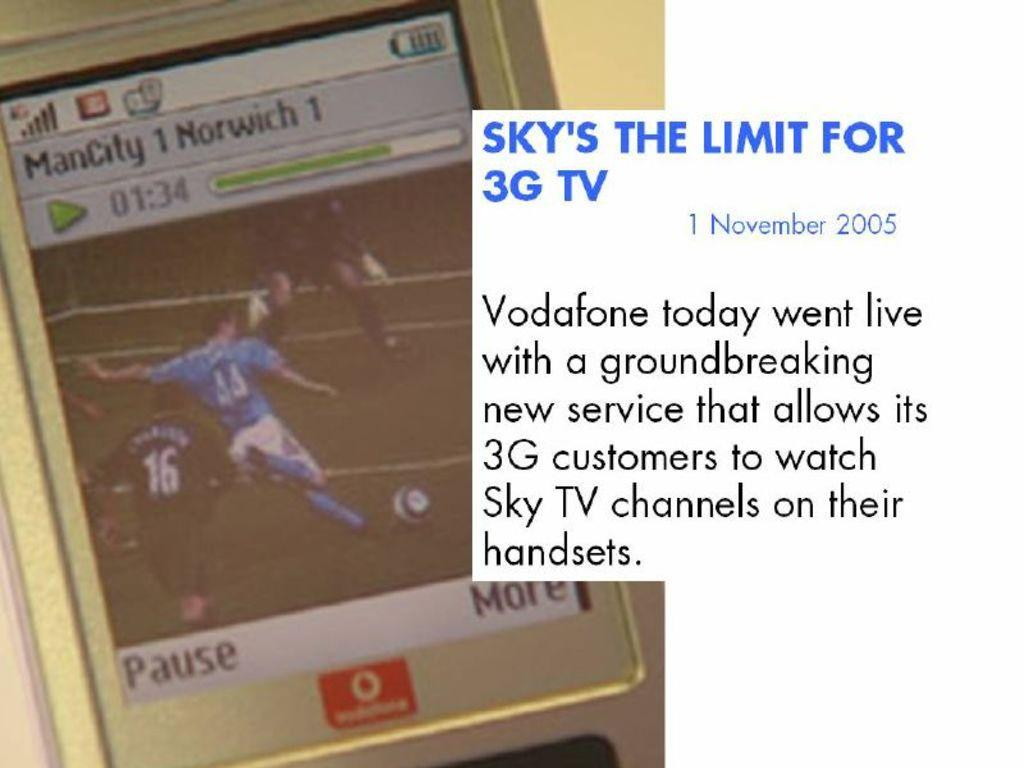What is the main subject of the image? The main subject of the image is a mobile screen. What is shown on the mobile screen? The mobile screen displays a group of people standing on the ground, a ball, and text. Can you describe the scene depicted on the mobile screen? The scene on the mobile screen shows a group of people standing on the ground with a ball nearby, and there is text present as well. What type of baby is visible in the image? There is no baby present in the image; it features a mobile screen displaying a group of people standing on the ground, a ball, and text. 